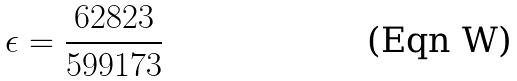Convert formula to latex. <formula><loc_0><loc_0><loc_500><loc_500>\epsilon = \frac { 6 2 8 2 3 } { 5 9 9 1 7 3 }</formula> 